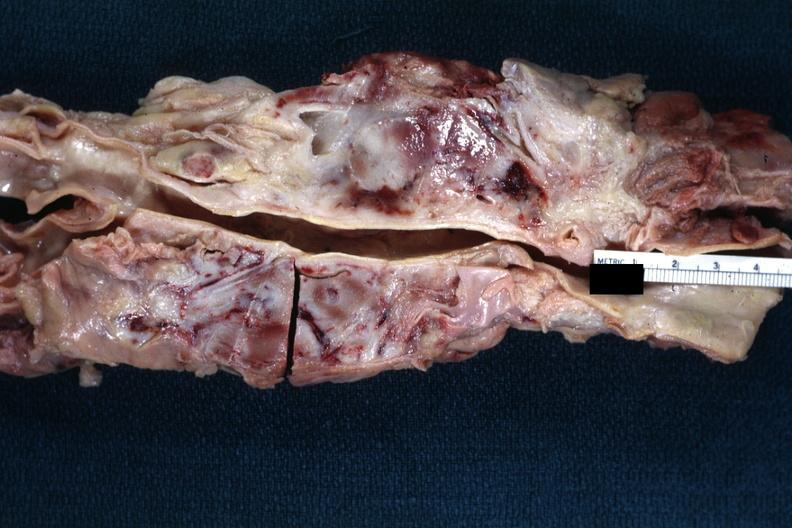s fixed tissue present?
Answer the question using a single word or phrase. No 